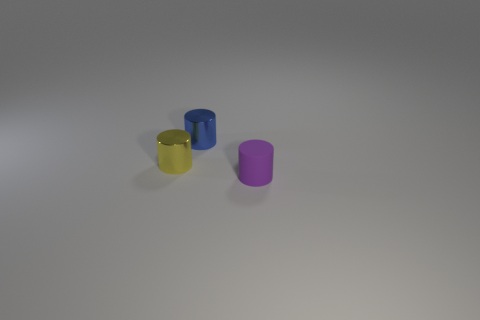There is a rubber cylinder that is on the right side of the blue cylinder; does it have the same color as the object that is on the left side of the blue object?
Keep it short and to the point. No. There is a purple rubber thing; how many small purple things are behind it?
Offer a terse response. 0. Does the cylinder in front of the yellow metallic cylinder have the same material as the tiny blue object?
Your response must be concise. No. How many tiny green spheres are the same material as the blue object?
Ensure brevity in your answer.  0. Is the number of small purple objects that are to the right of the small yellow thing greater than the number of big red shiny balls?
Provide a succinct answer. Yes. Are there any small blue objects that have the same shape as the small yellow metal object?
Give a very brief answer. Yes. What number of objects are either large brown rubber blocks or tiny yellow metal cylinders?
Make the answer very short. 1. There is a small thing that is to the right of the tiny cylinder that is behind the tiny yellow object; how many tiny yellow metal objects are right of it?
Your answer should be compact. 0. There is a tiny purple object that is the same shape as the blue thing; what is its material?
Your answer should be compact. Rubber. What is the material of the cylinder that is right of the yellow cylinder and in front of the small blue thing?
Provide a succinct answer. Rubber. 